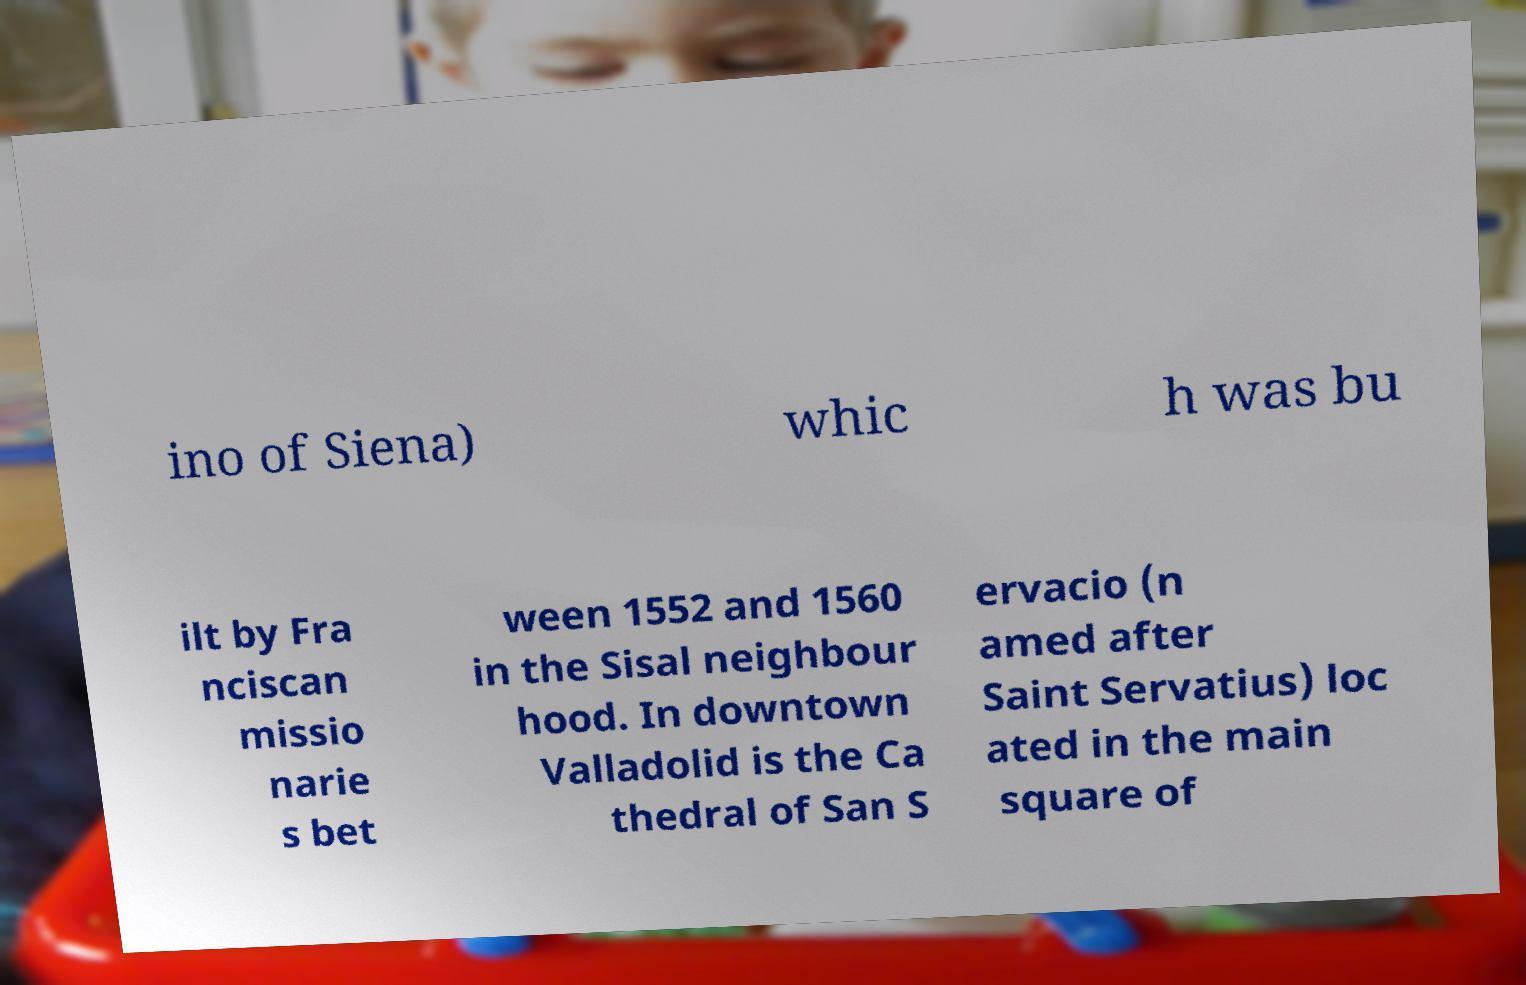Can you read and provide the text displayed in the image?This photo seems to have some interesting text. Can you extract and type it out for me? ino of Siena) whic h was bu ilt by Fra nciscan missio narie s bet ween 1552 and 1560 in the Sisal neighbour hood. In downtown Valladolid is the Ca thedral of San S ervacio (n amed after Saint Servatius) loc ated in the main square of 